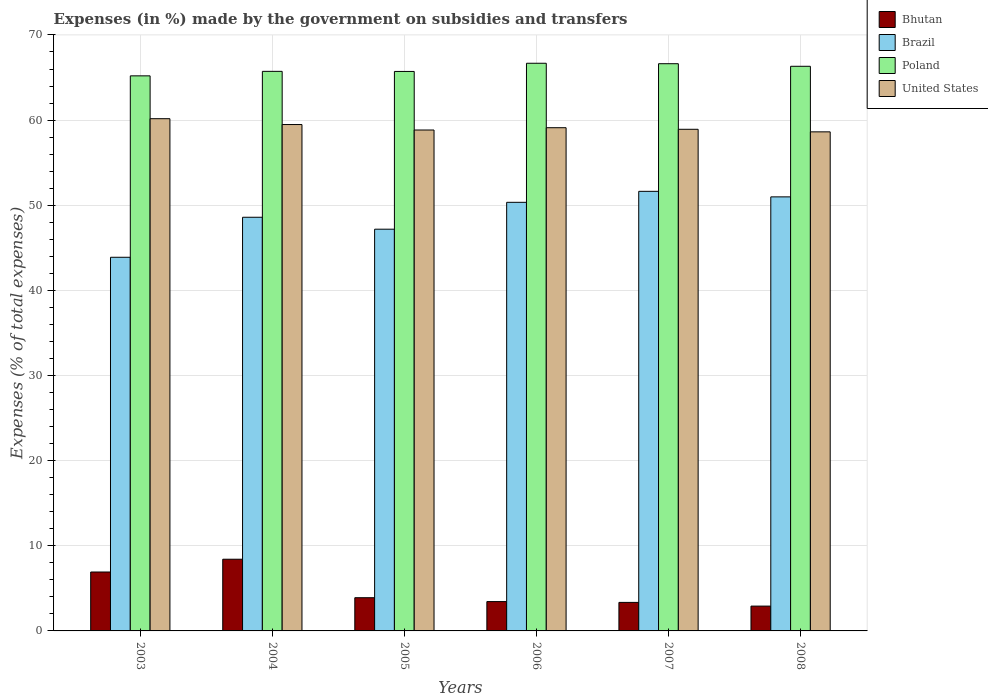How many different coloured bars are there?
Offer a terse response. 4. Are the number of bars per tick equal to the number of legend labels?
Provide a succinct answer. Yes. What is the percentage of expenses made by the government on subsidies and transfers in Brazil in 2008?
Offer a very short reply. 50.98. Across all years, what is the maximum percentage of expenses made by the government on subsidies and transfers in Bhutan?
Offer a terse response. 8.42. Across all years, what is the minimum percentage of expenses made by the government on subsidies and transfers in Poland?
Your answer should be very brief. 65.2. What is the total percentage of expenses made by the government on subsidies and transfers in Bhutan in the graph?
Ensure brevity in your answer.  28.95. What is the difference between the percentage of expenses made by the government on subsidies and transfers in Brazil in 2004 and that in 2008?
Offer a very short reply. -2.39. What is the difference between the percentage of expenses made by the government on subsidies and transfers in United States in 2007 and the percentage of expenses made by the government on subsidies and transfers in Poland in 2005?
Your answer should be very brief. -6.79. What is the average percentage of expenses made by the government on subsidies and transfers in Brazil per year?
Make the answer very short. 48.77. In the year 2007, what is the difference between the percentage of expenses made by the government on subsidies and transfers in Poland and percentage of expenses made by the government on subsidies and transfers in United States?
Ensure brevity in your answer.  7.7. What is the ratio of the percentage of expenses made by the government on subsidies and transfers in Brazil in 2003 to that in 2008?
Offer a terse response. 0.86. What is the difference between the highest and the second highest percentage of expenses made by the government on subsidies and transfers in Brazil?
Make the answer very short. 0.65. What is the difference between the highest and the lowest percentage of expenses made by the government on subsidies and transfers in Brazil?
Offer a terse response. 7.75. In how many years, is the percentage of expenses made by the government on subsidies and transfers in Bhutan greater than the average percentage of expenses made by the government on subsidies and transfers in Bhutan taken over all years?
Keep it short and to the point. 2. Is it the case that in every year, the sum of the percentage of expenses made by the government on subsidies and transfers in United States and percentage of expenses made by the government on subsidies and transfers in Poland is greater than the sum of percentage of expenses made by the government on subsidies and transfers in Brazil and percentage of expenses made by the government on subsidies and transfers in Bhutan?
Ensure brevity in your answer.  Yes. What does the 1st bar from the left in 2008 represents?
Keep it short and to the point. Bhutan. Is it the case that in every year, the sum of the percentage of expenses made by the government on subsidies and transfers in United States and percentage of expenses made by the government on subsidies and transfers in Bhutan is greater than the percentage of expenses made by the government on subsidies and transfers in Poland?
Ensure brevity in your answer.  No. How many bars are there?
Make the answer very short. 24. Are all the bars in the graph horizontal?
Your answer should be very brief. No. How many years are there in the graph?
Offer a terse response. 6. What is the difference between two consecutive major ticks on the Y-axis?
Make the answer very short. 10. Are the values on the major ticks of Y-axis written in scientific E-notation?
Provide a succinct answer. No. Does the graph contain grids?
Ensure brevity in your answer.  Yes. How many legend labels are there?
Give a very brief answer. 4. How are the legend labels stacked?
Your answer should be compact. Vertical. What is the title of the graph?
Ensure brevity in your answer.  Expenses (in %) made by the government on subsidies and transfers. What is the label or title of the X-axis?
Make the answer very short. Years. What is the label or title of the Y-axis?
Keep it short and to the point. Expenses (% of total expenses). What is the Expenses (% of total expenses) of Bhutan in 2003?
Make the answer very short. 6.92. What is the Expenses (% of total expenses) of Brazil in 2003?
Your response must be concise. 43.89. What is the Expenses (% of total expenses) in Poland in 2003?
Give a very brief answer. 65.2. What is the Expenses (% of total expenses) of United States in 2003?
Your answer should be compact. 60.16. What is the Expenses (% of total expenses) of Bhutan in 2004?
Offer a very short reply. 8.42. What is the Expenses (% of total expenses) in Brazil in 2004?
Offer a very short reply. 48.59. What is the Expenses (% of total expenses) in Poland in 2004?
Offer a very short reply. 65.72. What is the Expenses (% of total expenses) in United States in 2004?
Ensure brevity in your answer.  59.48. What is the Expenses (% of total expenses) of Bhutan in 2005?
Offer a terse response. 3.9. What is the Expenses (% of total expenses) in Brazil in 2005?
Keep it short and to the point. 47.18. What is the Expenses (% of total expenses) in Poland in 2005?
Give a very brief answer. 65.71. What is the Expenses (% of total expenses) of United States in 2005?
Your answer should be compact. 58.83. What is the Expenses (% of total expenses) of Bhutan in 2006?
Your answer should be very brief. 3.45. What is the Expenses (% of total expenses) in Brazil in 2006?
Offer a terse response. 50.34. What is the Expenses (% of total expenses) in Poland in 2006?
Offer a terse response. 66.67. What is the Expenses (% of total expenses) of United States in 2006?
Your response must be concise. 59.1. What is the Expenses (% of total expenses) of Bhutan in 2007?
Provide a short and direct response. 3.35. What is the Expenses (% of total expenses) of Brazil in 2007?
Provide a short and direct response. 51.63. What is the Expenses (% of total expenses) in Poland in 2007?
Provide a short and direct response. 66.62. What is the Expenses (% of total expenses) of United States in 2007?
Give a very brief answer. 58.92. What is the Expenses (% of total expenses) in Bhutan in 2008?
Your answer should be compact. 2.92. What is the Expenses (% of total expenses) in Brazil in 2008?
Keep it short and to the point. 50.98. What is the Expenses (% of total expenses) in Poland in 2008?
Your response must be concise. 66.32. What is the Expenses (% of total expenses) in United States in 2008?
Offer a terse response. 58.62. Across all years, what is the maximum Expenses (% of total expenses) in Bhutan?
Provide a short and direct response. 8.42. Across all years, what is the maximum Expenses (% of total expenses) in Brazil?
Your response must be concise. 51.63. Across all years, what is the maximum Expenses (% of total expenses) of Poland?
Your response must be concise. 66.67. Across all years, what is the maximum Expenses (% of total expenses) of United States?
Keep it short and to the point. 60.16. Across all years, what is the minimum Expenses (% of total expenses) in Bhutan?
Ensure brevity in your answer.  2.92. Across all years, what is the minimum Expenses (% of total expenses) of Brazil?
Offer a terse response. 43.89. Across all years, what is the minimum Expenses (% of total expenses) of Poland?
Your answer should be compact. 65.2. Across all years, what is the minimum Expenses (% of total expenses) in United States?
Keep it short and to the point. 58.62. What is the total Expenses (% of total expenses) in Bhutan in the graph?
Offer a very short reply. 28.95. What is the total Expenses (% of total expenses) in Brazil in the graph?
Keep it short and to the point. 292.61. What is the total Expenses (% of total expenses) of Poland in the graph?
Keep it short and to the point. 396.25. What is the total Expenses (% of total expenses) in United States in the graph?
Provide a short and direct response. 355.12. What is the difference between the Expenses (% of total expenses) of Bhutan in 2003 and that in 2004?
Keep it short and to the point. -1.5. What is the difference between the Expenses (% of total expenses) of Brazil in 2003 and that in 2004?
Your answer should be compact. -4.7. What is the difference between the Expenses (% of total expenses) in Poland in 2003 and that in 2004?
Your answer should be compact. -0.53. What is the difference between the Expenses (% of total expenses) in United States in 2003 and that in 2004?
Provide a short and direct response. 0.69. What is the difference between the Expenses (% of total expenses) of Bhutan in 2003 and that in 2005?
Provide a short and direct response. 3.02. What is the difference between the Expenses (% of total expenses) in Brazil in 2003 and that in 2005?
Offer a terse response. -3.3. What is the difference between the Expenses (% of total expenses) of Poland in 2003 and that in 2005?
Offer a terse response. -0.52. What is the difference between the Expenses (% of total expenses) in United States in 2003 and that in 2005?
Give a very brief answer. 1.33. What is the difference between the Expenses (% of total expenses) in Bhutan in 2003 and that in 2006?
Offer a very short reply. 3.47. What is the difference between the Expenses (% of total expenses) of Brazil in 2003 and that in 2006?
Provide a short and direct response. -6.45. What is the difference between the Expenses (% of total expenses) in Poland in 2003 and that in 2006?
Offer a terse response. -1.48. What is the difference between the Expenses (% of total expenses) in United States in 2003 and that in 2006?
Ensure brevity in your answer.  1.06. What is the difference between the Expenses (% of total expenses) in Bhutan in 2003 and that in 2007?
Your response must be concise. 3.57. What is the difference between the Expenses (% of total expenses) of Brazil in 2003 and that in 2007?
Your answer should be very brief. -7.75. What is the difference between the Expenses (% of total expenses) of Poland in 2003 and that in 2007?
Provide a short and direct response. -1.43. What is the difference between the Expenses (% of total expenses) of United States in 2003 and that in 2007?
Your answer should be compact. 1.25. What is the difference between the Expenses (% of total expenses) of Bhutan in 2003 and that in 2008?
Offer a very short reply. 4. What is the difference between the Expenses (% of total expenses) of Brazil in 2003 and that in 2008?
Ensure brevity in your answer.  -7.1. What is the difference between the Expenses (% of total expenses) of Poland in 2003 and that in 2008?
Make the answer very short. -1.12. What is the difference between the Expenses (% of total expenses) in United States in 2003 and that in 2008?
Give a very brief answer. 1.55. What is the difference between the Expenses (% of total expenses) of Bhutan in 2004 and that in 2005?
Offer a terse response. 4.52. What is the difference between the Expenses (% of total expenses) in Brazil in 2004 and that in 2005?
Ensure brevity in your answer.  1.4. What is the difference between the Expenses (% of total expenses) in Poland in 2004 and that in 2005?
Provide a short and direct response. 0.01. What is the difference between the Expenses (% of total expenses) of United States in 2004 and that in 2005?
Your response must be concise. 0.64. What is the difference between the Expenses (% of total expenses) of Bhutan in 2004 and that in 2006?
Make the answer very short. 4.98. What is the difference between the Expenses (% of total expenses) in Brazil in 2004 and that in 2006?
Give a very brief answer. -1.75. What is the difference between the Expenses (% of total expenses) of Poland in 2004 and that in 2006?
Your response must be concise. -0.95. What is the difference between the Expenses (% of total expenses) of United States in 2004 and that in 2006?
Your answer should be compact. 0.37. What is the difference between the Expenses (% of total expenses) of Bhutan in 2004 and that in 2007?
Keep it short and to the point. 5.07. What is the difference between the Expenses (% of total expenses) of Brazil in 2004 and that in 2007?
Keep it short and to the point. -3.05. What is the difference between the Expenses (% of total expenses) of Poland in 2004 and that in 2007?
Provide a succinct answer. -0.9. What is the difference between the Expenses (% of total expenses) of United States in 2004 and that in 2007?
Ensure brevity in your answer.  0.56. What is the difference between the Expenses (% of total expenses) in Bhutan in 2004 and that in 2008?
Make the answer very short. 5.51. What is the difference between the Expenses (% of total expenses) of Brazil in 2004 and that in 2008?
Your response must be concise. -2.39. What is the difference between the Expenses (% of total expenses) of Poland in 2004 and that in 2008?
Keep it short and to the point. -0.59. What is the difference between the Expenses (% of total expenses) in United States in 2004 and that in 2008?
Keep it short and to the point. 0.86. What is the difference between the Expenses (% of total expenses) in Bhutan in 2005 and that in 2006?
Provide a short and direct response. 0.45. What is the difference between the Expenses (% of total expenses) of Brazil in 2005 and that in 2006?
Your response must be concise. -3.16. What is the difference between the Expenses (% of total expenses) of Poland in 2005 and that in 2006?
Provide a short and direct response. -0.96. What is the difference between the Expenses (% of total expenses) of United States in 2005 and that in 2006?
Ensure brevity in your answer.  -0.27. What is the difference between the Expenses (% of total expenses) in Bhutan in 2005 and that in 2007?
Provide a succinct answer. 0.55. What is the difference between the Expenses (% of total expenses) in Brazil in 2005 and that in 2007?
Your answer should be very brief. -4.45. What is the difference between the Expenses (% of total expenses) of Poland in 2005 and that in 2007?
Your answer should be very brief. -0.91. What is the difference between the Expenses (% of total expenses) in United States in 2005 and that in 2007?
Provide a succinct answer. -0.08. What is the difference between the Expenses (% of total expenses) in Bhutan in 2005 and that in 2008?
Your answer should be compact. 0.98. What is the difference between the Expenses (% of total expenses) of Brazil in 2005 and that in 2008?
Give a very brief answer. -3.8. What is the difference between the Expenses (% of total expenses) in Poland in 2005 and that in 2008?
Offer a very short reply. -0.61. What is the difference between the Expenses (% of total expenses) of United States in 2005 and that in 2008?
Keep it short and to the point. 0.22. What is the difference between the Expenses (% of total expenses) in Bhutan in 2006 and that in 2007?
Your answer should be very brief. 0.1. What is the difference between the Expenses (% of total expenses) in Brazil in 2006 and that in 2007?
Your answer should be very brief. -1.29. What is the difference between the Expenses (% of total expenses) of Poland in 2006 and that in 2007?
Offer a terse response. 0.05. What is the difference between the Expenses (% of total expenses) in United States in 2006 and that in 2007?
Give a very brief answer. 0.19. What is the difference between the Expenses (% of total expenses) of Bhutan in 2006 and that in 2008?
Your answer should be compact. 0.53. What is the difference between the Expenses (% of total expenses) in Brazil in 2006 and that in 2008?
Your answer should be very brief. -0.64. What is the difference between the Expenses (% of total expenses) in Poland in 2006 and that in 2008?
Your response must be concise. 0.36. What is the difference between the Expenses (% of total expenses) in United States in 2006 and that in 2008?
Your answer should be compact. 0.49. What is the difference between the Expenses (% of total expenses) in Bhutan in 2007 and that in 2008?
Your answer should be compact. 0.43. What is the difference between the Expenses (% of total expenses) in Brazil in 2007 and that in 2008?
Keep it short and to the point. 0.65. What is the difference between the Expenses (% of total expenses) of Poland in 2007 and that in 2008?
Your response must be concise. 0.3. What is the difference between the Expenses (% of total expenses) in United States in 2007 and that in 2008?
Make the answer very short. 0.3. What is the difference between the Expenses (% of total expenses) in Bhutan in 2003 and the Expenses (% of total expenses) in Brazil in 2004?
Keep it short and to the point. -41.67. What is the difference between the Expenses (% of total expenses) of Bhutan in 2003 and the Expenses (% of total expenses) of Poland in 2004?
Provide a short and direct response. -58.8. What is the difference between the Expenses (% of total expenses) of Bhutan in 2003 and the Expenses (% of total expenses) of United States in 2004?
Ensure brevity in your answer.  -52.56. What is the difference between the Expenses (% of total expenses) of Brazil in 2003 and the Expenses (% of total expenses) of Poland in 2004?
Provide a short and direct response. -21.84. What is the difference between the Expenses (% of total expenses) in Brazil in 2003 and the Expenses (% of total expenses) in United States in 2004?
Make the answer very short. -15.59. What is the difference between the Expenses (% of total expenses) of Poland in 2003 and the Expenses (% of total expenses) of United States in 2004?
Ensure brevity in your answer.  5.72. What is the difference between the Expenses (% of total expenses) in Bhutan in 2003 and the Expenses (% of total expenses) in Brazil in 2005?
Give a very brief answer. -40.27. What is the difference between the Expenses (% of total expenses) of Bhutan in 2003 and the Expenses (% of total expenses) of Poland in 2005?
Provide a short and direct response. -58.79. What is the difference between the Expenses (% of total expenses) in Bhutan in 2003 and the Expenses (% of total expenses) in United States in 2005?
Your answer should be compact. -51.92. What is the difference between the Expenses (% of total expenses) in Brazil in 2003 and the Expenses (% of total expenses) in Poland in 2005?
Your answer should be compact. -21.83. What is the difference between the Expenses (% of total expenses) in Brazil in 2003 and the Expenses (% of total expenses) in United States in 2005?
Provide a succinct answer. -14.95. What is the difference between the Expenses (% of total expenses) of Poland in 2003 and the Expenses (% of total expenses) of United States in 2005?
Provide a succinct answer. 6.36. What is the difference between the Expenses (% of total expenses) of Bhutan in 2003 and the Expenses (% of total expenses) of Brazil in 2006?
Offer a terse response. -43.42. What is the difference between the Expenses (% of total expenses) in Bhutan in 2003 and the Expenses (% of total expenses) in Poland in 2006?
Make the answer very short. -59.76. What is the difference between the Expenses (% of total expenses) in Bhutan in 2003 and the Expenses (% of total expenses) in United States in 2006?
Offer a terse response. -52.18. What is the difference between the Expenses (% of total expenses) in Brazil in 2003 and the Expenses (% of total expenses) in Poland in 2006?
Offer a terse response. -22.79. What is the difference between the Expenses (% of total expenses) in Brazil in 2003 and the Expenses (% of total expenses) in United States in 2006?
Ensure brevity in your answer.  -15.22. What is the difference between the Expenses (% of total expenses) in Poland in 2003 and the Expenses (% of total expenses) in United States in 2006?
Make the answer very short. 6.09. What is the difference between the Expenses (% of total expenses) of Bhutan in 2003 and the Expenses (% of total expenses) of Brazil in 2007?
Make the answer very short. -44.71. What is the difference between the Expenses (% of total expenses) of Bhutan in 2003 and the Expenses (% of total expenses) of Poland in 2007?
Offer a very short reply. -59.7. What is the difference between the Expenses (% of total expenses) in Bhutan in 2003 and the Expenses (% of total expenses) in United States in 2007?
Your answer should be compact. -52. What is the difference between the Expenses (% of total expenses) of Brazil in 2003 and the Expenses (% of total expenses) of Poland in 2007?
Your answer should be compact. -22.74. What is the difference between the Expenses (% of total expenses) of Brazil in 2003 and the Expenses (% of total expenses) of United States in 2007?
Ensure brevity in your answer.  -15.03. What is the difference between the Expenses (% of total expenses) of Poland in 2003 and the Expenses (% of total expenses) of United States in 2007?
Keep it short and to the point. 6.28. What is the difference between the Expenses (% of total expenses) in Bhutan in 2003 and the Expenses (% of total expenses) in Brazil in 2008?
Make the answer very short. -44.06. What is the difference between the Expenses (% of total expenses) of Bhutan in 2003 and the Expenses (% of total expenses) of Poland in 2008?
Provide a short and direct response. -59.4. What is the difference between the Expenses (% of total expenses) in Bhutan in 2003 and the Expenses (% of total expenses) in United States in 2008?
Your answer should be compact. -51.7. What is the difference between the Expenses (% of total expenses) of Brazil in 2003 and the Expenses (% of total expenses) of Poland in 2008?
Make the answer very short. -22.43. What is the difference between the Expenses (% of total expenses) in Brazil in 2003 and the Expenses (% of total expenses) in United States in 2008?
Keep it short and to the point. -14.73. What is the difference between the Expenses (% of total expenses) in Poland in 2003 and the Expenses (% of total expenses) in United States in 2008?
Provide a succinct answer. 6.58. What is the difference between the Expenses (% of total expenses) of Bhutan in 2004 and the Expenses (% of total expenses) of Brazil in 2005?
Your response must be concise. -38.76. What is the difference between the Expenses (% of total expenses) in Bhutan in 2004 and the Expenses (% of total expenses) in Poland in 2005?
Your answer should be compact. -57.29. What is the difference between the Expenses (% of total expenses) of Bhutan in 2004 and the Expenses (% of total expenses) of United States in 2005?
Offer a very short reply. -50.41. What is the difference between the Expenses (% of total expenses) of Brazil in 2004 and the Expenses (% of total expenses) of Poland in 2005?
Offer a very short reply. -17.13. What is the difference between the Expenses (% of total expenses) in Brazil in 2004 and the Expenses (% of total expenses) in United States in 2005?
Your answer should be compact. -10.25. What is the difference between the Expenses (% of total expenses) of Poland in 2004 and the Expenses (% of total expenses) of United States in 2005?
Offer a terse response. 6.89. What is the difference between the Expenses (% of total expenses) in Bhutan in 2004 and the Expenses (% of total expenses) in Brazil in 2006?
Give a very brief answer. -41.92. What is the difference between the Expenses (% of total expenses) in Bhutan in 2004 and the Expenses (% of total expenses) in Poland in 2006?
Ensure brevity in your answer.  -58.25. What is the difference between the Expenses (% of total expenses) of Bhutan in 2004 and the Expenses (% of total expenses) of United States in 2006?
Offer a terse response. -50.68. What is the difference between the Expenses (% of total expenses) in Brazil in 2004 and the Expenses (% of total expenses) in Poland in 2006?
Keep it short and to the point. -18.09. What is the difference between the Expenses (% of total expenses) in Brazil in 2004 and the Expenses (% of total expenses) in United States in 2006?
Offer a terse response. -10.52. What is the difference between the Expenses (% of total expenses) in Poland in 2004 and the Expenses (% of total expenses) in United States in 2006?
Provide a succinct answer. 6.62. What is the difference between the Expenses (% of total expenses) in Bhutan in 2004 and the Expenses (% of total expenses) in Brazil in 2007?
Your answer should be very brief. -43.21. What is the difference between the Expenses (% of total expenses) of Bhutan in 2004 and the Expenses (% of total expenses) of Poland in 2007?
Make the answer very short. -58.2. What is the difference between the Expenses (% of total expenses) in Bhutan in 2004 and the Expenses (% of total expenses) in United States in 2007?
Offer a very short reply. -50.5. What is the difference between the Expenses (% of total expenses) of Brazil in 2004 and the Expenses (% of total expenses) of Poland in 2007?
Provide a succinct answer. -18.04. What is the difference between the Expenses (% of total expenses) of Brazil in 2004 and the Expenses (% of total expenses) of United States in 2007?
Give a very brief answer. -10.33. What is the difference between the Expenses (% of total expenses) in Poland in 2004 and the Expenses (% of total expenses) in United States in 2007?
Give a very brief answer. 6.81. What is the difference between the Expenses (% of total expenses) in Bhutan in 2004 and the Expenses (% of total expenses) in Brazil in 2008?
Your response must be concise. -42.56. What is the difference between the Expenses (% of total expenses) in Bhutan in 2004 and the Expenses (% of total expenses) in Poland in 2008?
Your answer should be compact. -57.9. What is the difference between the Expenses (% of total expenses) in Bhutan in 2004 and the Expenses (% of total expenses) in United States in 2008?
Give a very brief answer. -50.2. What is the difference between the Expenses (% of total expenses) in Brazil in 2004 and the Expenses (% of total expenses) in Poland in 2008?
Offer a very short reply. -17.73. What is the difference between the Expenses (% of total expenses) of Brazil in 2004 and the Expenses (% of total expenses) of United States in 2008?
Offer a terse response. -10.03. What is the difference between the Expenses (% of total expenses) of Poland in 2004 and the Expenses (% of total expenses) of United States in 2008?
Offer a very short reply. 7.11. What is the difference between the Expenses (% of total expenses) in Bhutan in 2005 and the Expenses (% of total expenses) in Brazil in 2006?
Give a very brief answer. -46.44. What is the difference between the Expenses (% of total expenses) of Bhutan in 2005 and the Expenses (% of total expenses) of Poland in 2006?
Give a very brief answer. -62.77. What is the difference between the Expenses (% of total expenses) in Bhutan in 2005 and the Expenses (% of total expenses) in United States in 2006?
Ensure brevity in your answer.  -55.2. What is the difference between the Expenses (% of total expenses) of Brazil in 2005 and the Expenses (% of total expenses) of Poland in 2006?
Your answer should be compact. -19.49. What is the difference between the Expenses (% of total expenses) in Brazil in 2005 and the Expenses (% of total expenses) in United States in 2006?
Offer a very short reply. -11.92. What is the difference between the Expenses (% of total expenses) in Poland in 2005 and the Expenses (% of total expenses) in United States in 2006?
Keep it short and to the point. 6.61. What is the difference between the Expenses (% of total expenses) of Bhutan in 2005 and the Expenses (% of total expenses) of Brazil in 2007?
Provide a short and direct response. -47.73. What is the difference between the Expenses (% of total expenses) of Bhutan in 2005 and the Expenses (% of total expenses) of Poland in 2007?
Your response must be concise. -62.72. What is the difference between the Expenses (% of total expenses) in Bhutan in 2005 and the Expenses (% of total expenses) in United States in 2007?
Offer a terse response. -55.02. What is the difference between the Expenses (% of total expenses) in Brazil in 2005 and the Expenses (% of total expenses) in Poland in 2007?
Offer a terse response. -19.44. What is the difference between the Expenses (% of total expenses) of Brazil in 2005 and the Expenses (% of total expenses) of United States in 2007?
Provide a succinct answer. -11.73. What is the difference between the Expenses (% of total expenses) of Poland in 2005 and the Expenses (% of total expenses) of United States in 2007?
Offer a very short reply. 6.79. What is the difference between the Expenses (% of total expenses) of Bhutan in 2005 and the Expenses (% of total expenses) of Brazil in 2008?
Your response must be concise. -47.08. What is the difference between the Expenses (% of total expenses) of Bhutan in 2005 and the Expenses (% of total expenses) of Poland in 2008?
Provide a short and direct response. -62.42. What is the difference between the Expenses (% of total expenses) of Bhutan in 2005 and the Expenses (% of total expenses) of United States in 2008?
Give a very brief answer. -54.72. What is the difference between the Expenses (% of total expenses) in Brazil in 2005 and the Expenses (% of total expenses) in Poland in 2008?
Your response must be concise. -19.13. What is the difference between the Expenses (% of total expenses) of Brazil in 2005 and the Expenses (% of total expenses) of United States in 2008?
Give a very brief answer. -11.43. What is the difference between the Expenses (% of total expenses) of Poland in 2005 and the Expenses (% of total expenses) of United States in 2008?
Offer a very short reply. 7.09. What is the difference between the Expenses (% of total expenses) of Bhutan in 2006 and the Expenses (% of total expenses) of Brazil in 2007?
Make the answer very short. -48.19. What is the difference between the Expenses (% of total expenses) of Bhutan in 2006 and the Expenses (% of total expenses) of Poland in 2007?
Keep it short and to the point. -63.18. What is the difference between the Expenses (% of total expenses) of Bhutan in 2006 and the Expenses (% of total expenses) of United States in 2007?
Your response must be concise. -55.47. What is the difference between the Expenses (% of total expenses) of Brazil in 2006 and the Expenses (% of total expenses) of Poland in 2007?
Offer a very short reply. -16.28. What is the difference between the Expenses (% of total expenses) in Brazil in 2006 and the Expenses (% of total expenses) in United States in 2007?
Give a very brief answer. -8.58. What is the difference between the Expenses (% of total expenses) in Poland in 2006 and the Expenses (% of total expenses) in United States in 2007?
Provide a succinct answer. 7.76. What is the difference between the Expenses (% of total expenses) of Bhutan in 2006 and the Expenses (% of total expenses) of Brazil in 2008?
Make the answer very short. -47.53. What is the difference between the Expenses (% of total expenses) of Bhutan in 2006 and the Expenses (% of total expenses) of Poland in 2008?
Your response must be concise. -62.87. What is the difference between the Expenses (% of total expenses) in Bhutan in 2006 and the Expenses (% of total expenses) in United States in 2008?
Your answer should be very brief. -55.17. What is the difference between the Expenses (% of total expenses) of Brazil in 2006 and the Expenses (% of total expenses) of Poland in 2008?
Make the answer very short. -15.98. What is the difference between the Expenses (% of total expenses) in Brazil in 2006 and the Expenses (% of total expenses) in United States in 2008?
Your response must be concise. -8.28. What is the difference between the Expenses (% of total expenses) in Poland in 2006 and the Expenses (% of total expenses) in United States in 2008?
Give a very brief answer. 8.06. What is the difference between the Expenses (% of total expenses) of Bhutan in 2007 and the Expenses (% of total expenses) of Brazil in 2008?
Give a very brief answer. -47.63. What is the difference between the Expenses (% of total expenses) in Bhutan in 2007 and the Expenses (% of total expenses) in Poland in 2008?
Provide a short and direct response. -62.97. What is the difference between the Expenses (% of total expenses) in Bhutan in 2007 and the Expenses (% of total expenses) in United States in 2008?
Make the answer very short. -55.27. What is the difference between the Expenses (% of total expenses) of Brazil in 2007 and the Expenses (% of total expenses) of Poland in 2008?
Give a very brief answer. -14.69. What is the difference between the Expenses (% of total expenses) in Brazil in 2007 and the Expenses (% of total expenses) in United States in 2008?
Provide a short and direct response. -6.99. What is the difference between the Expenses (% of total expenses) in Poland in 2007 and the Expenses (% of total expenses) in United States in 2008?
Your answer should be compact. 8. What is the average Expenses (% of total expenses) of Bhutan per year?
Your response must be concise. 4.83. What is the average Expenses (% of total expenses) in Brazil per year?
Your response must be concise. 48.77. What is the average Expenses (% of total expenses) in Poland per year?
Keep it short and to the point. 66.04. What is the average Expenses (% of total expenses) of United States per year?
Offer a terse response. 59.19. In the year 2003, what is the difference between the Expenses (% of total expenses) of Bhutan and Expenses (% of total expenses) of Brazil?
Provide a short and direct response. -36.97. In the year 2003, what is the difference between the Expenses (% of total expenses) of Bhutan and Expenses (% of total expenses) of Poland?
Your answer should be very brief. -58.28. In the year 2003, what is the difference between the Expenses (% of total expenses) of Bhutan and Expenses (% of total expenses) of United States?
Make the answer very short. -53.24. In the year 2003, what is the difference between the Expenses (% of total expenses) of Brazil and Expenses (% of total expenses) of Poland?
Provide a short and direct response. -21.31. In the year 2003, what is the difference between the Expenses (% of total expenses) in Brazil and Expenses (% of total expenses) in United States?
Keep it short and to the point. -16.28. In the year 2003, what is the difference between the Expenses (% of total expenses) in Poland and Expenses (% of total expenses) in United States?
Your answer should be very brief. 5.03. In the year 2004, what is the difference between the Expenses (% of total expenses) in Bhutan and Expenses (% of total expenses) in Brazil?
Provide a short and direct response. -40.16. In the year 2004, what is the difference between the Expenses (% of total expenses) of Bhutan and Expenses (% of total expenses) of Poland?
Provide a short and direct response. -57.3. In the year 2004, what is the difference between the Expenses (% of total expenses) in Bhutan and Expenses (% of total expenses) in United States?
Your answer should be very brief. -51.06. In the year 2004, what is the difference between the Expenses (% of total expenses) of Brazil and Expenses (% of total expenses) of Poland?
Ensure brevity in your answer.  -17.14. In the year 2004, what is the difference between the Expenses (% of total expenses) in Brazil and Expenses (% of total expenses) in United States?
Keep it short and to the point. -10.89. In the year 2004, what is the difference between the Expenses (% of total expenses) in Poland and Expenses (% of total expenses) in United States?
Ensure brevity in your answer.  6.25. In the year 2005, what is the difference between the Expenses (% of total expenses) of Bhutan and Expenses (% of total expenses) of Brazil?
Make the answer very short. -43.28. In the year 2005, what is the difference between the Expenses (% of total expenses) in Bhutan and Expenses (% of total expenses) in Poland?
Offer a terse response. -61.81. In the year 2005, what is the difference between the Expenses (% of total expenses) of Bhutan and Expenses (% of total expenses) of United States?
Provide a short and direct response. -54.93. In the year 2005, what is the difference between the Expenses (% of total expenses) of Brazil and Expenses (% of total expenses) of Poland?
Make the answer very short. -18.53. In the year 2005, what is the difference between the Expenses (% of total expenses) in Brazil and Expenses (% of total expenses) in United States?
Keep it short and to the point. -11.65. In the year 2005, what is the difference between the Expenses (% of total expenses) in Poland and Expenses (% of total expenses) in United States?
Give a very brief answer. 6.88. In the year 2006, what is the difference between the Expenses (% of total expenses) in Bhutan and Expenses (% of total expenses) in Brazil?
Give a very brief answer. -46.89. In the year 2006, what is the difference between the Expenses (% of total expenses) of Bhutan and Expenses (% of total expenses) of Poland?
Offer a very short reply. -63.23. In the year 2006, what is the difference between the Expenses (% of total expenses) of Bhutan and Expenses (% of total expenses) of United States?
Make the answer very short. -55.66. In the year 2006, what is the difference between the Expenses (% of total expenses) in Brazil and Expenses (% of total expenses) in Poland?
Offer a very short reply. -16.33. In the year 2006, what is the difference between the Expenses (% of total expenses) in Brazil and Expenses (% of total expenses) in United States?
Your answer should be very brief. -8.76. In the year 2006, what is the difference between the Expenses (% of total expenses) in Poland and Expenses (% of total expenses) in United States?
Make the answer very short. 7.57. In the year 2007, what is the difference between the Expenses (% of total expenses) of Bhutan and Expenses (% of total expenses) of Brazil?
Give a very brief answer. -48.28. In the year 2007, what is the difference between the Expenses (% of total expenses) of Bhutan and Expenses (% of total expenses) of Poland?
Provide a short and direct response. -63.27. In the year 2007, what is the difference between the Expenses (% of total expenses) in Bhutan and Expenses (% of total expenses) in United States?
Make the answer very short. -55.57. In the year 2007, what is the difference between the Expenses (% of total expenses) in Brazil and Expenses (% of total expenses) in Poland?
Your answer should be very brief. -14.99. In the year 2007, what is the difference between the Expenses (% of total expenses) of Brazil and Expenses (% of total expenses) of United States?
Ensure brevity in your answer.  -7.29. In the year 2007, what is the difference between the Expenses (% of total expenses) of Poland and Expenses (% of total expenses) of United States?
Give a very brief answer. 7.7. In the year 2008, what is the difference between the Expenses (% of total expenses) of Bhutan and Expenses (% of total expenses) of Brazil?
Make the answer very short. -48.07. In the year 2008, what is the difference between the Expenses (% of total expenses) in Bhutan and Expenses (% of total expenses) in Poland?
Keep it short and to the point. -63.4. In the year 2008, what is the difference between the Expenses (% of total expenses) in Bhutan and Expenses (% of total expenses) in United States?
Ensure brevity in your answer.  -55.7. In the year 2008, what is the difference between the Expenses (% of total expenses) in Brazil and Expenses (% of total expenses) in Poland?
Keep it short and to the point. -15.34. In the year 2008, what is the difference between the Expenses (% of total expenses) in Brazil and Expenses (% of total expenses) in United States?
Ensure brevity in your answer.  -7.64. In the year 2008, what is the difference between the Expenses (% of total expenses) in Poland and Expenses (% of total expenses) in United States?
Ensure brevity in your answer.  7.7. What is the ratio of the Expenses (% of total expenses) of Bhutan in 2003 to that in 2004?
Make the answer very short. 0.82. What is the ratio of the Expenses (% of total expenses) of Brazil in 2003 to that in 2004?
Keep it short and to the point. 0.9. What is the ratio of the Expenses (% of total expenses) in Poland in 2003 to that in 2004?
Provide a short and direct response. 0.99. What is the ratio of the Expenses (% of total expenses) in United States in 2003 to that in 2004?
Provide a succinct answer. 1.01. What is the ratio of the Expenses (% of total expenses) in Bhutan in 2003 to that in 2005?
Your answer should be very brief. 1.77. What is the ratio of the Expenses (% of total expenses) in Brazil in 2003 to that in 2005?
Your answer should be very brief. 0.93. What is the ratio of the Expenses (% of total expenses) in United States in 2003 to that in 2005?
Ensure brevity in your answer.  1.02. What is the ratio of the Expenses (% of total expenses) in Bhutan in 2003 to that in 2006?
Give a very brief answer. 2.01. What is the ratio of the Expenses (% of total expenses) in Brazil in 2003 to that in 2006?
Offer a terse response. 0.87. What is the ratio of the Expenses (% of total expenses) of Poland in 2003 to that in 2006?
Provide a short and direct response. 0.98. What is the ratio of the Expenses (% of total expenses) in United States in 2003 to that in 2006?
Offer a terse response. 1.02. What is the ratio of the Expenses (% of total expenses) of Bhutan in 2003 to that in 2007?
Your answer should be very brief. 2.07. What is the ratio of the Expenses (% of total expenses) in Poland in 2003 to that in 2007?
Your answer should be very brief. 0.98. What is the ratio of the Expenses (% of total expenses) of United States in 2003 to that in 2007?
Keep it short and to the point. 1.02. What is the ratio of the Expenses (% of total expenses) of Bhutan in 2003 to that in 2008?
Ensure brevity in your answer.  2.37. What is the ratio of the Expenses (% of total expenses) in Brazil in 2003 to that in 2008?
Keep it short and to the point. 0.86. What is the ratio of the Expenses (% of total expenses) of Poland in 2003 to that in 2008?
Your answer should be very brief. 0.98. What is the ratio of the Expenses (% of total expenses) in United States in 2003 to that in 2008?
Your answer should be compact. 1.03. What is the ratio of the Expenses (% of total expenses) of Bhutan in 2004 to that in 2005?
Give a very brief answer. 2.16. What is the ratio of the Expenses (% of total expenses) of Brazil in 2004 to that in 2005?
Give a very brief answer. 1.03. What is the ratio of the Expenses (% of total expenses) of United States in 2004 to that in 2005?
Your answer should be very brief. 1.01. What is the ratio of the Expenses (% of total expenses) of Bhutan in 2004 to that in 2006?
Provide a short and direct response. 2.44. What is the ratio of the Expenses (% of total expenses) in Brazil in 2004 to that in 2006?
Your answer should be compact. 0.97. What is the ratio of the Expenses (% of total expenses) in Poland in 2004 to that in 2006?
Your answer should be compact. 0.99. What is the ratio of the Expenses (% of total expenses) in Bhutan in 2004 to that in 2007?
Offer a very short reply. 2.51. What is the ratio of the Expenses (% of total expenses) in Brazil in 2004 to that in 2007?
Offer a very short reply. 0.94. What is the ratio of the Expenses (% of total expenses) of Poland in 2004 to that in 2007?
Provide a short and direct response. 0.99. What is the ratio of the Expenses (% of total expenses) in United States in 2004 to that in 2007?
Offer a terse response. 1.01. What is the ratio of the Expenses (% of total expenses) in Bhutan in 2004 to that in 2008?
Your response must be concise. 2.89. What is the ratio of the Expenses (% of total expenses) in Brazil in 2004 to that in 2008?
Provide a succinct answer. 0.95. What is the ratio of the Expenses (% of total expenses) in Poland in 2004 to that in 2008?
Make the answer very short. 0.99. What is the ratio of the Expenses (% of total expenses) in United States in 2004 to that in 2008?
Give a very brief answer. 1.01. What is the ratio of the Expenses (% of total expenses) of Bhutan in 2005 to that in 2006?
Make the answer very short. 1.13. What is the ratio of the Expenses (% of total expenses) of Brazil in 2005 to that in 2006?
Your answer should be compact. 0.94. What is the ratio of the Expenses (% of total expenses) in Poland in 2005 to that in 2006?
Your response must be concise. 0.99. What is the ratio of the Expenses (% of total expenses) of Bhutan in 2005 to that in 2007?
Your answer should be compact. 1.16. What is the ratio of the Expenses (% of total expenses) of Brazil in 2005 to that in 2007?
Make the answer very short. 0.91. What is the ratio of the Expenses (% of total expenses) in Poland in 2005 to that in 2007?
Your answer should be compact. 0.99. What is the ratio of the Expenses (% of total expenses) in Bhutan in 2005 to that in 2008?
Your answer should be very brief. 1.34. What is the ratio of the Expenses (% of total expenses) in Brazil in 2005 to that in 2008?
Ensure brevity in your answer.  0.93. What is the ratio of the Expenses (% of total expenses) in Poland in 2005 to that in 2008?
Provide a short and direct response. 0.99. What is the ratio of the Expenses (% of total expenses) in Bhutan in 2006 to that in 2007?
Offer a very short reply. 1.03. What is the ratio of the Expenses (% of total expenses) of United States in 2006 to that in 2007?
Your answer should be very brief. 1. What is the ratio of the Expenses (% of total expenses) of Bhutan in 2006 to that in 2008?
Ensure brevity in your answer.  1.18. What is the ratio of the Expenses (% of total expenses) in Brazil in 2006 to that in 2008?
Provide a succinct answer. 0.99. What is the ratio of the Expenses (% of total expenses) in Poland in 2006 to that in 2008?
Provide a succinct answer. 1.01. What is the ratio of the Expenses (% of total expenses) of United States in 2006 to that in 2008?
Give a very brief answer. 1.01. What is the ratio of the Expenses (% of total expenses) of Bhutan in 2007 to that in 2008?
Make the answer very short. 1.15. What is the ratio of the Expenses (% of total expenses) in Brazil in 2007 to that in 2008?
Your answer should be compact. 1.01. What is the ratio of the Expenses (% of total expenses) in United States in 2007 to that in 2008?
Your response must be concise. 1.01. What is the difference between the highest and the second highest Expenses (% of total expenses) in Bhutan?
Provide a short and direct response. 1.5. What is the difference between the highest and the second highest Expenses (% of total expenses) in Brazil?
Ensure brevity in your answer.  0.65. What is the difference between the highest and the second highest Expenses (% of total expenses) of Poland?
Provide a short and direct response. 0.05. What is the difference between the highest and the second highest Expenses (% of total expenses) of United States?
Offer a terse response. 0.69. What is the difference between the highest and the lowest Expenses (% of total expenses) of Bhutan?
Offer a terse response. 5.51. What is the difference between the highest and the lowest Expenses (% of total expenses) in Brazil?
Provide a succinct answer. 7.75. What is the difference between the highest and the lowest Expenses (% of total expenses) in Poland?
Keep it short and to the point. 1.48. What is the difference between the highest and the lowest Expenses (% of total expenses) of United States?
Offer a very short reply. 1.55. 